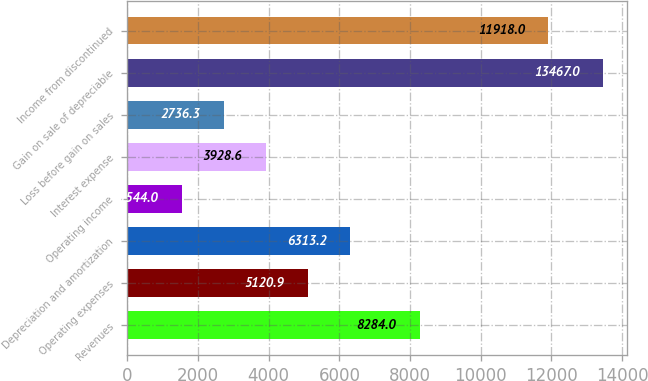Convert chart to OTSL. <chart><loc_0><loc_0><loc_500><loc_500><bar_chart><fcel>Revenues<fcel>Operating expenses<fcel>Depreciation and amortization<fcel>Operating income<fcel>Interest expense<fcel>Loss before gain on sales<fcel>Gain on sale of depreciable<fcel>Income from discontinued<nl><fcel>8284<fcel>5120.9<fcel>6313.2<fcel>1544<fcel>3928.6<fcel>2736.3<fcel>13467<fcel>11918<nl></chart> 